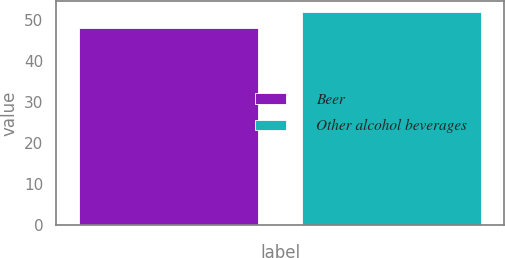Convert chart. <chart><loc_0><loc_0><loc_500><loc_500><bar_chart><fcel>Beer<fcel>Other alcohol beverages<nl><fcel>48<fcel>52<nl></chart> 